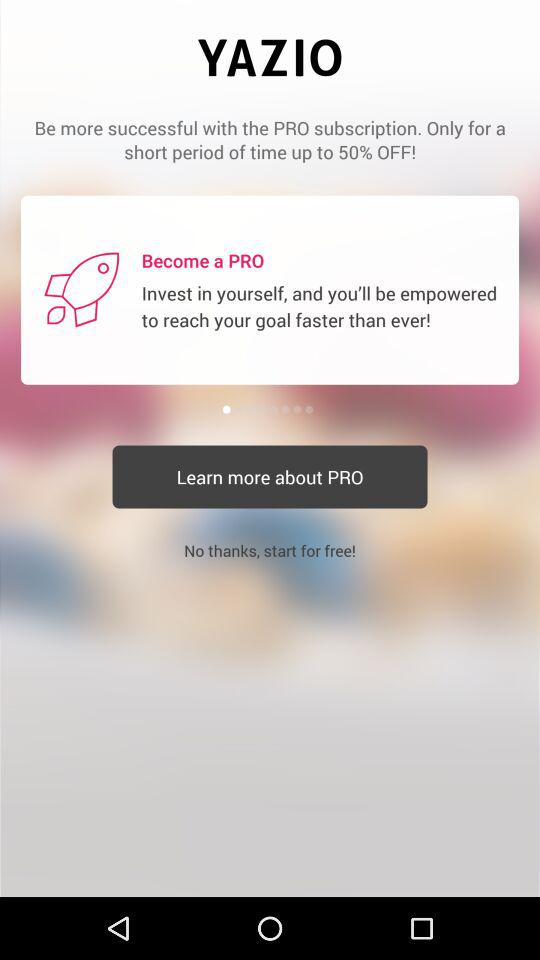What is the name of the application? The name of the application is "YAZIO". 